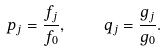Convert formula to latex. <formula><loc_0><loc_0><loc_500><loc_500>p _ { j } = \frac { f _ { j } } { f _ { 0 } } , \quad q _ { j } = \frac { g _ { j } } { g _ { 0 } } .</formula> 